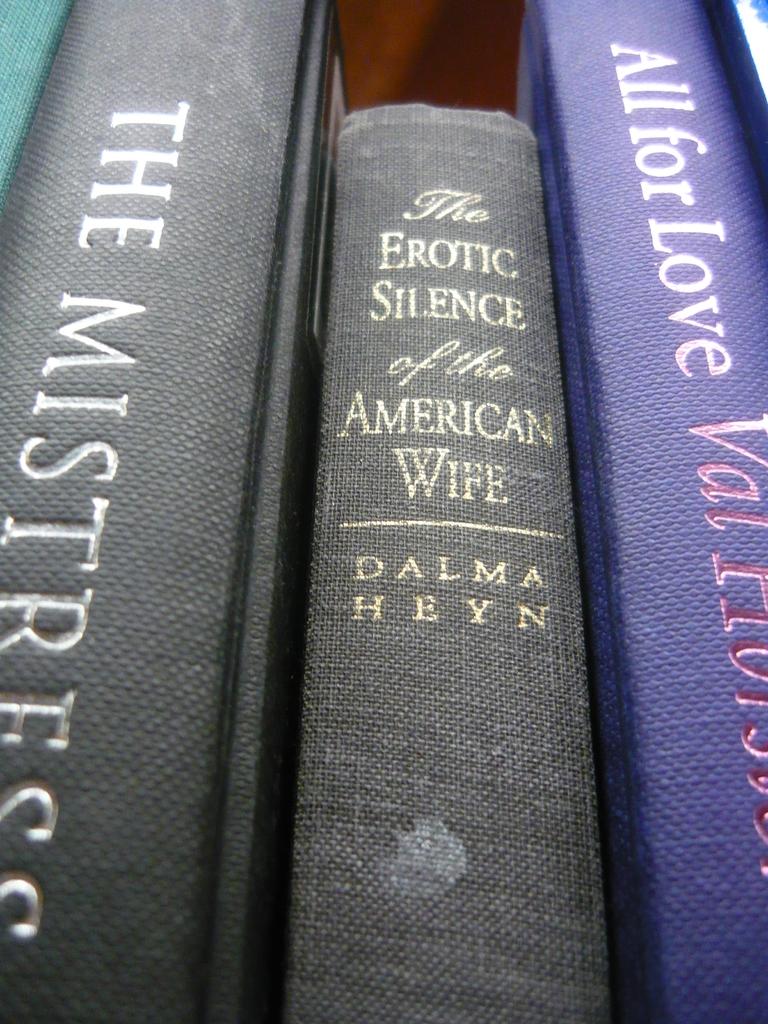Who wrote the book?
Ensure brevity in your answer.  Dalma heyn. 